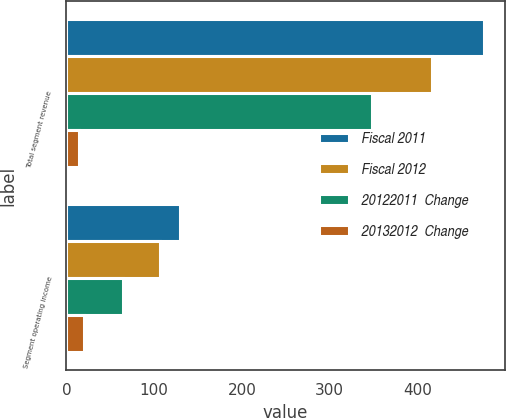<chart> <loc_0><loc_0><loc_500><loc_500><stacked_bar_chart><ecel><fcel>Total segment revenue<fcel>Segment operating income<nl><fcel>Fiscal 2011<fcel>476<fcel>129<nl><fcel>Fiscal 2012<fcel>417<fcel>107<nl><fcel>20122011  Change<fcel>348<fcel>64<nl><fcel>20132012  Change<fcel>14<fcel>20<nl></chart> 